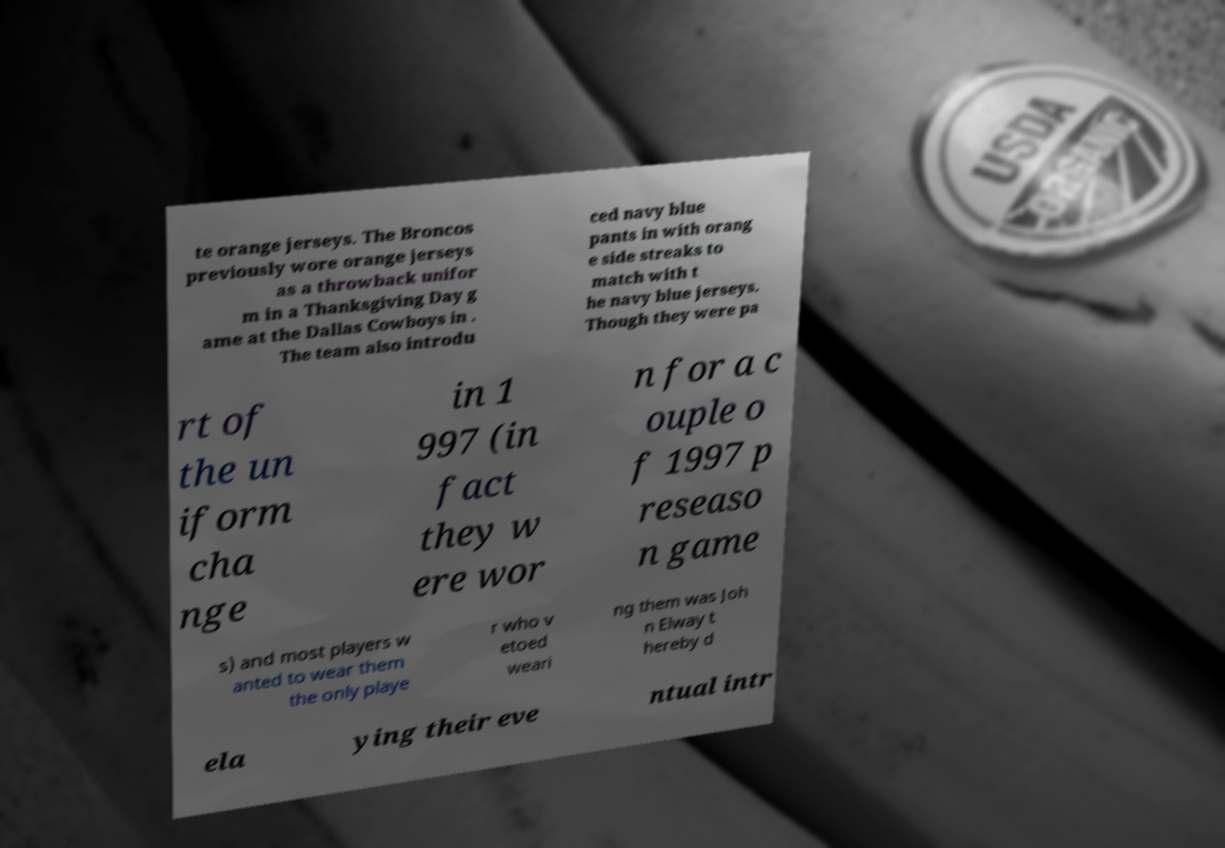Please identify and transcribe the text found in this image. te orange jerseys. The Broncos previously wore orange jerseys as a throwback unifor m in a Thanksgiving Day g ame at the Dallas Cowboys in . The team also introdu ced navy blue pants in with orang e side streaks to match with t he navy blue jerseys. Though they were pa rt of the un iform cha nge in 1 997 (in fact they w ere wor n for a c ouple o f 1997 p reseaso n game s) and most players w anted to wear them the only playe r who v etoed weari ng them was Joh n Elway t hereby d ela ying their eve ntual intr 